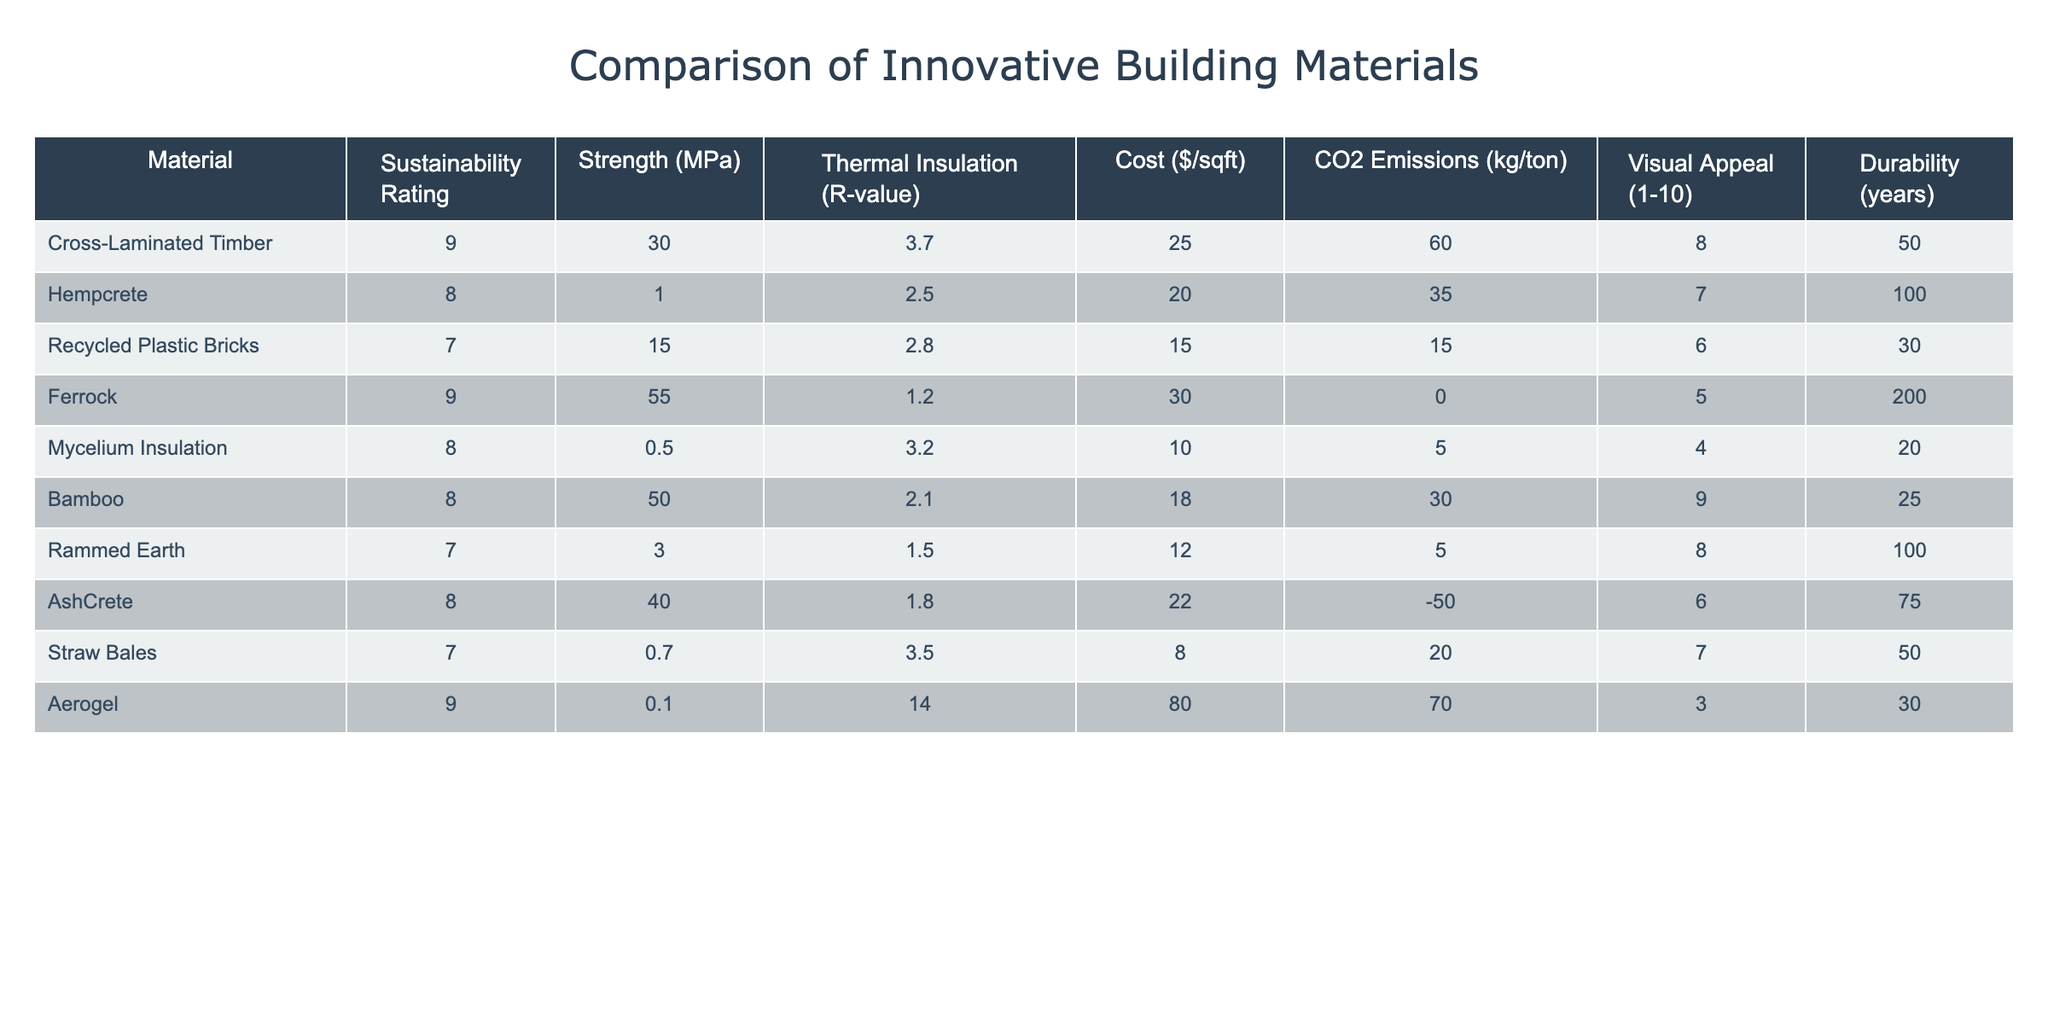What is the sustainability rating of Cross-Laminated Timber? The table shows that the sustainability rating of Cross-Laminated Timber is 9.
Answer: 9 Which material has the highest strength? By examining the Strength column, Ferrock has the highest value at 55 MPa, compared to the others.
Answer: Ferrock Is the cost per square foot of Hempcrete lower than that of Bamboo? Hempcrete is listed at $20/sqft while Bamboo is $18/sqft; since 20 is greater than 18, the statement is false.
Answer: No What is the average durability of all the materials listed? To find the average durability, sum the durability values (50 + 100 + 30 + 200 + 20 + 25 + 100 + 75 + 50 + 30 = 880), then divide by the number of materials (10). Thus, 880/10 = 88.
Answer: 88 Which materials have a sustainability rating greater than 8? Reviewing the sustainability ratings, Cross-Laminated Timber (9), Ferrock (9), Hempcrete (8), and Bamboo (8) have ratings greater than 8.
Answer: Cross-Laminated Timber, Ferrock, Hempcrete, Bamboo Does Aerogel have better thermal insulation than Mycelium Insulation? Aerogel has an R-value of 14, and Mycelium Insulation has an R-value of 3.2. Since 14 is greater than 3.2, the statement is true.
Answer: Yes What is the total CO2 emissions of all materials combined? Summing up the CO2 emissions values gives (60 + 35 + 15 + 0 + 5 - 50 + 20 + 0 + 70 = 155 kg/ton).
Answer: 155 Which material has the lowest visual appeal rating? The visual appeal rating for Ferrock is 5, which is the lowest compared to the others listed in the table.
Answer: Ferrock How much more does the strongest material cost per square foot compared to the weakest material? The strongest material is Ferrock at $30/sqft, while the weakest in strength is Mycelium Insulation at $10/sqft. The difference is 30 - 10 = 20.
Answer: 20 